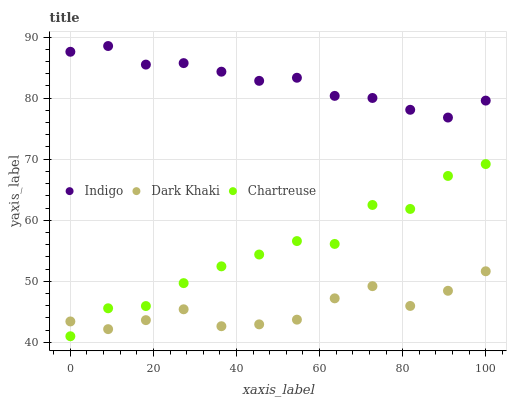Does Dark Khaki have the minimum area under the curve?
Answer yes or no. Yes. Does Indigo have the maximum area under the curve?
Answer yes or no. Yes. Does Chartreuse have the minimum area under the curve?
Answer yes or no. No. Does Chartreuse have the maximum area under the curve?
Answer yes or no. No. Is Indigo the smoothest?
Answer yes or no. Yes. Is Chartreuse the roughest?
Answer yes or no. Yes. Is Chartreuse the smoothest?
Answer yes or no. No. Is Indigo the roughest?
Answer yes or no. No. Does Chartreuse have the lowest value?
Answer yes or no. Yes. Does Indigo have the lowest value?
Answer yes or no. No. Does Indigo have the highest value?
Answer yes or no. Yes. Does Chartreuse have the highest value?
Answer yes or no. No. Is Dark Khaki less than Indigo?
Answer yes or no. Yes. Is Indigo greater than Dark Khaki?
Answer yes or no. Yes. Does Chartreuse intersect Dark Khaki?
Answer yes or no. Yes. Is Chartreuse less than Dark Khaki?
Answer yes or no. No. Is Chartreuse greater than Dark Khaki?
Answer yes or no. No. Does Dark Khaki intersect Indigo?
Answer yes or no. No. 